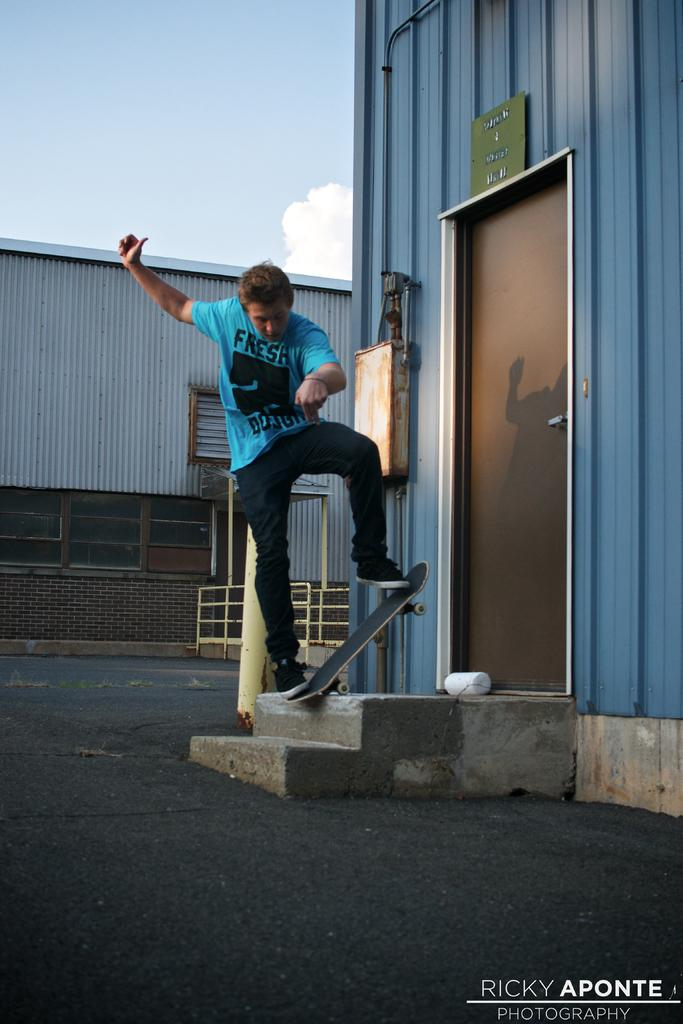What is the person in the image doing? The person is standing on a skateboard in the image. Where is the skateboard located? The skateboard is on the steps. What can be seen on the right side of the image? There is a house on the right side of the image. What is visible in the background of the image? The sky is visible in the background of the image. What type of stone is the person using to balance on the skateboard? There is no stone present in the image; the person is standing on a skateboard. What material is the woolen sweater the person is wearing made of? The person is not wearing a woolen sweater in the image; there is no mention of clothing. 